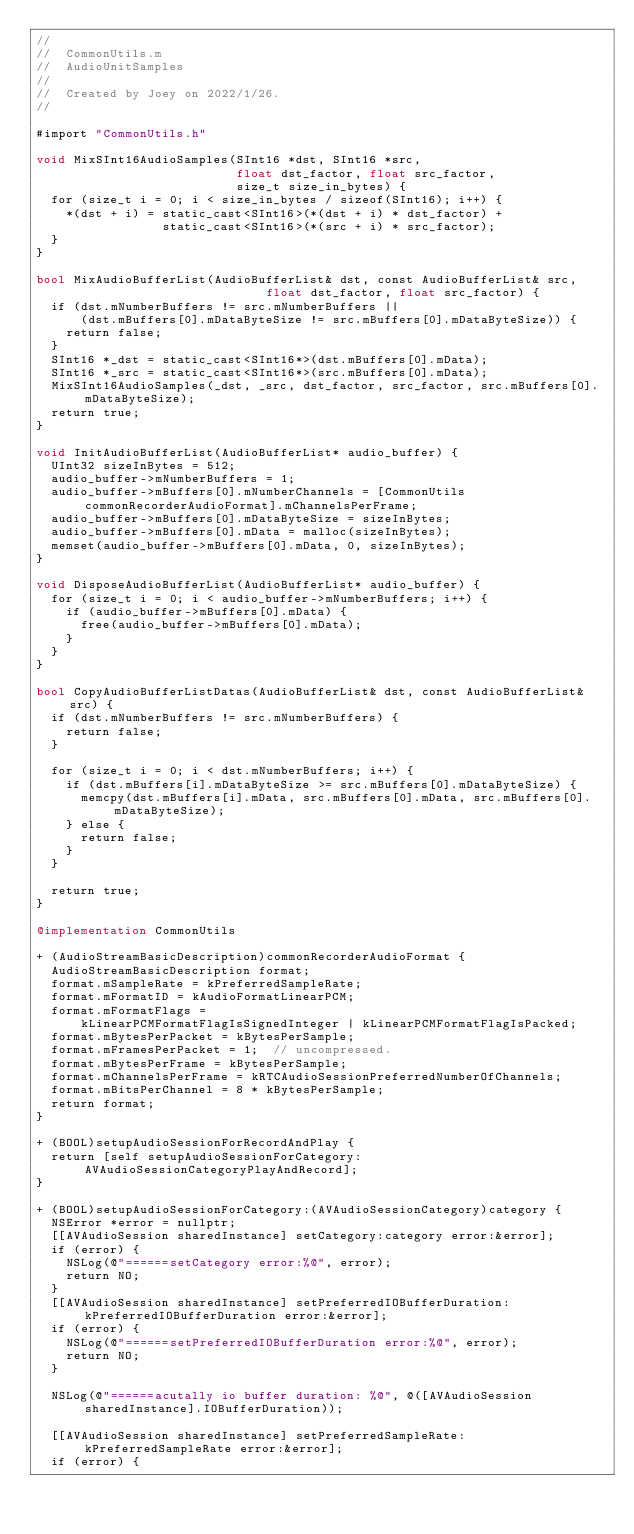<code> <loc_0><loc_0><loc_500><loc_500><_ObjectiveC_>//
//  CommonUtils.m
//  AudioUnitSamples
//
//  Created by Joey on 2022/1/26.
//

#import "CommonUtils.h"

void MixSInt16AudioSamples(SInt16 *dst, SInt16 *src,
                           float dst_factor, float src_factor,
                           size_t size_in_bytes) {
  for (size_t i = 0; i < size_in_bytes / sizeof(SInt16); i++) {
    *(dst + i) = static_cast<SInt16>(*(dst + i) * dst_factor) +
                 static_cast<SInt16>(*(src + i) * src_factor);
  }
}

bool MixAudioBufferList(AudioBufferList& dst, const AudioBufferList& src,
                               float dst_factor, float src_factor) {
  if (dst.mNumberBuffers != src.mNumberBuffers ||
      (dst.mBuffers[0].mDataByteSize != src.mBuffers[0].mDataByteSize)) {
    return false;
  }
  SInt16 *_dst = static_cast<SInt16*>(dst.mBuffers[0].mData);
  SInt16 *_src = static_cast<SInt16*>(src.mBuffers[0].mData);
  MixSInt16AudioSamples(_dst, _src, dst_factor, src_factor, src.mBuffers[0].mDataByteSize);
  return true;
}

void InitAudioBufferList(AudioBufferList* audio_buffer) {
  UInt32 sizeInBytes = 512;
  audio_buffer->mNumberBuffers = 1;
  audio_buffer->mBuffers[0].mNumberChannels = [CommonUtils commonRecorderAudioFormat].mChannelsPerFrame;
  audio_buffer->mBuffers[0].mDataByteSize = sizeInBytes;
  audio_buffer->mBuffers[0].mData = malloc(sizeInBytes);
  memset(audio_buffer->mBuffers[0].mData, 0, sizeInBytes);
}

void DisposeAudioBufferList(AudioBufferList* audio_buffer) {
  for (size_t i = 0; i < audio_buffer->mNumberBuffers; i++) {
    if (audio_buffer->mBuffers[0].mData) {
      free(audio_buffer->mBuffers[0].mData);
    }
  }
}

bool CopyAudioBufferListDatas(AudioBufferList& dst, const AudioBufferList& src) {
  if (dst.mNumberBuffers != src.mNumberBuffers) {
    return false;
  }
  
  for (size_t i = 0; i < dst.mNumberBuffers; i++) {
    if (dst.mBuffers[i].mDataByteSize >= src.mBuffers[0].mDataByteSize) {
      memcpy(dst.mBuffers[i].mData, src.mBuffers[0].mData, src.mBuffers[0].mDataByteSize);
    } else {
      return false;
    }
  }

  return true;
}

@implementation CommonUtils

+ (AudioStreamBasicDescription)commonRecorderAudioFormat {
  AudioStreamBasicDescription format;
  format.mSampleRate = kPreferredSampleRate;
  format.mFormatID = kAudioFormatLinearPCM;
  format.mFormatFlags =
      kLinearPCMFormatFlagIsSignedInteger | kLinearPCMFormatFlagIsPacked;
  format.mBytesPerPacket = kBytesPerSample;
  format.mFramesPerPacket = 1;  // uncompressed.
  format.mBytesPerFrame = kBytesPerSample;
  format.mChannelsPerFrame = kRTCAudioSessionPreferredNumberOfChannels;
  format.mBitsPerChannel = 8 * kBytesPerSample;
  return format;
}

+ (BOOL)setupAudioSessionForRecordAndPlay {
  return [self setupAudioSessionForCategory:AVAudioSessionCategoryPlayAndRecord];
}

+ (BOOL)setupAudioSessionForCategory:(AVAudioSessionCategory)category {
  NSError *error = nullptr;
  [[AVAudioSession sharedInstance] setCategory:category error:&error];
  if (error) {
    NSLog(@"======setCategory error:%@", error);
    return NO;
  }
  [[AVAudioSession sharedInstance] setPreferredIOBufferDuration:kPreferredIOBufferDuration error:&error];
  if (error) {
    NSLog(@"======setPreferredIOBufferDuration error:%@", error);
    return NO;
  }
  
  NSLog(@"======acutally io buffer duration: %@", @([AVAudioSession sharedInstance].IOBufferDuration));
  
  [[AVAudioSession sharedInstance] setPreferredSampleRate:kPreferredSampleRate error:&error];
  if (error) {</code> 